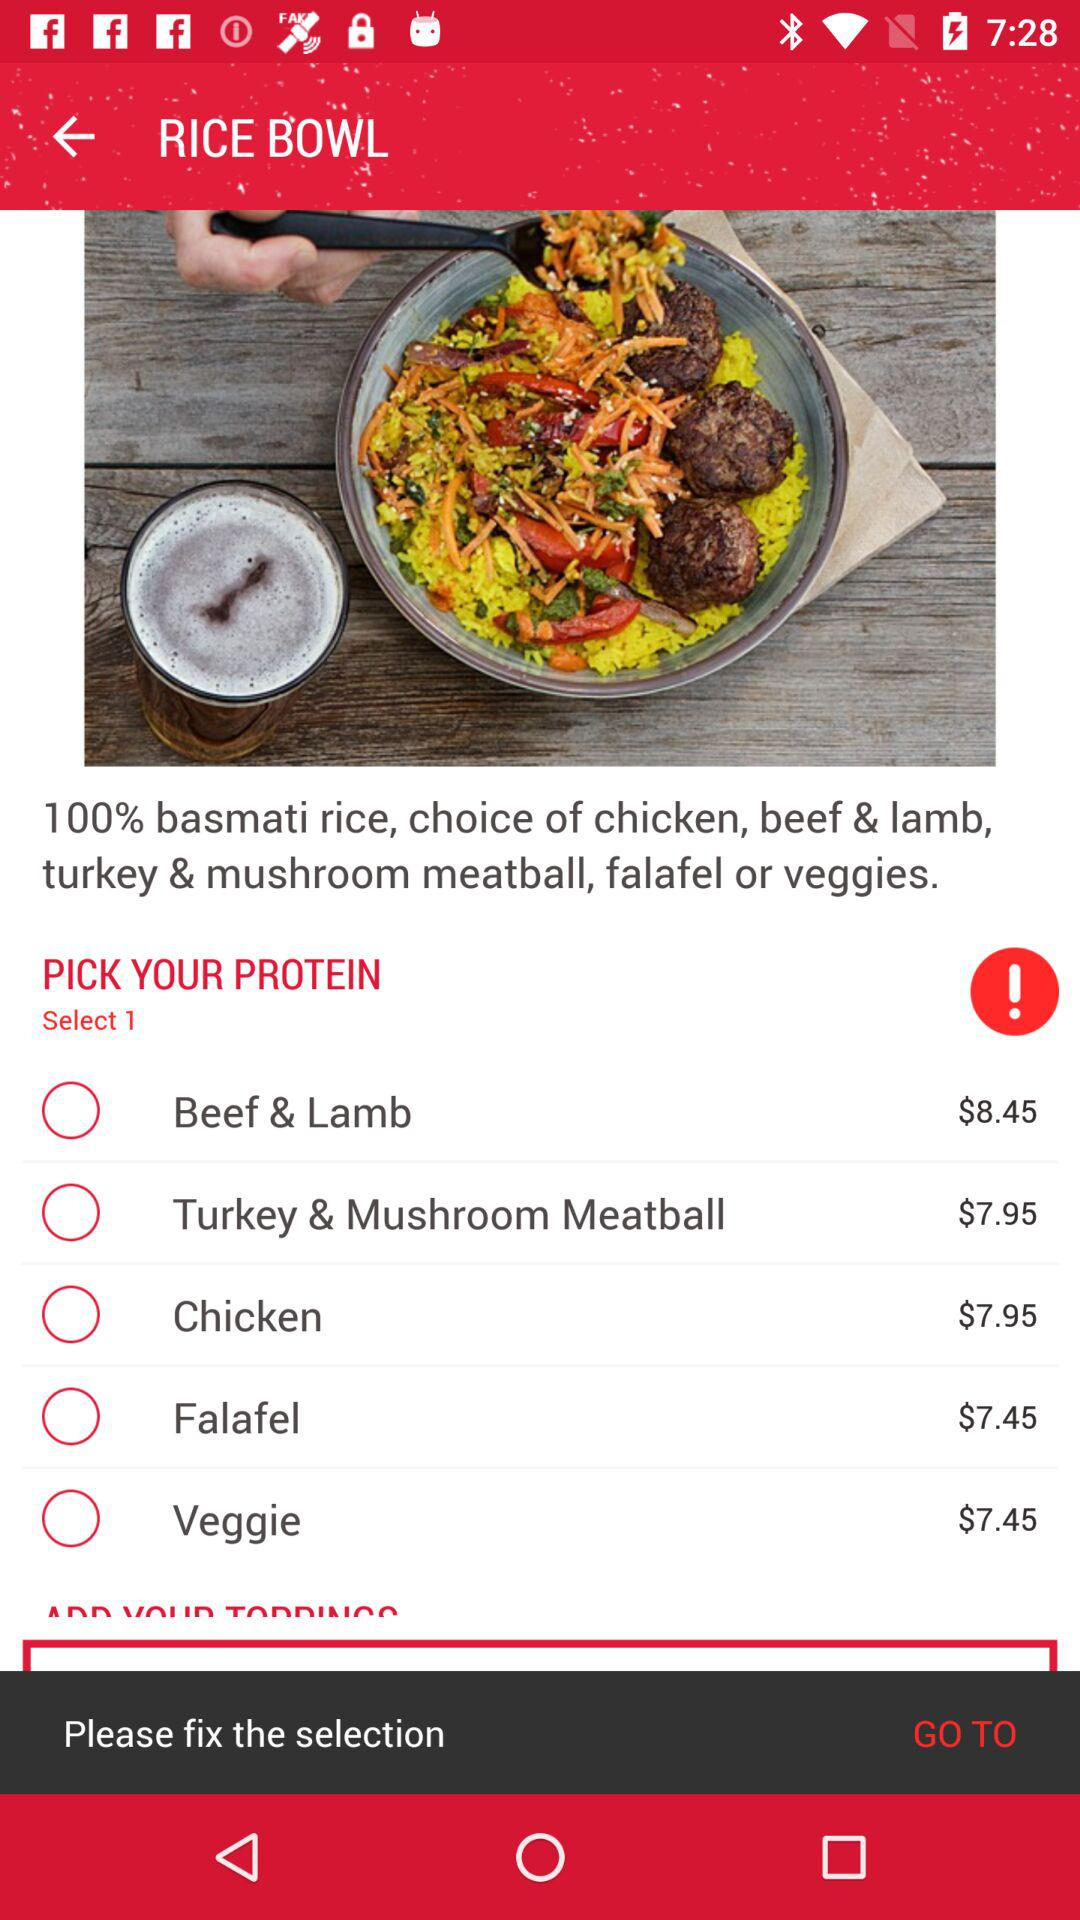What's the cost of "Beef & Lamb"? The cost of "Beef & Lamb" is $8.45. 